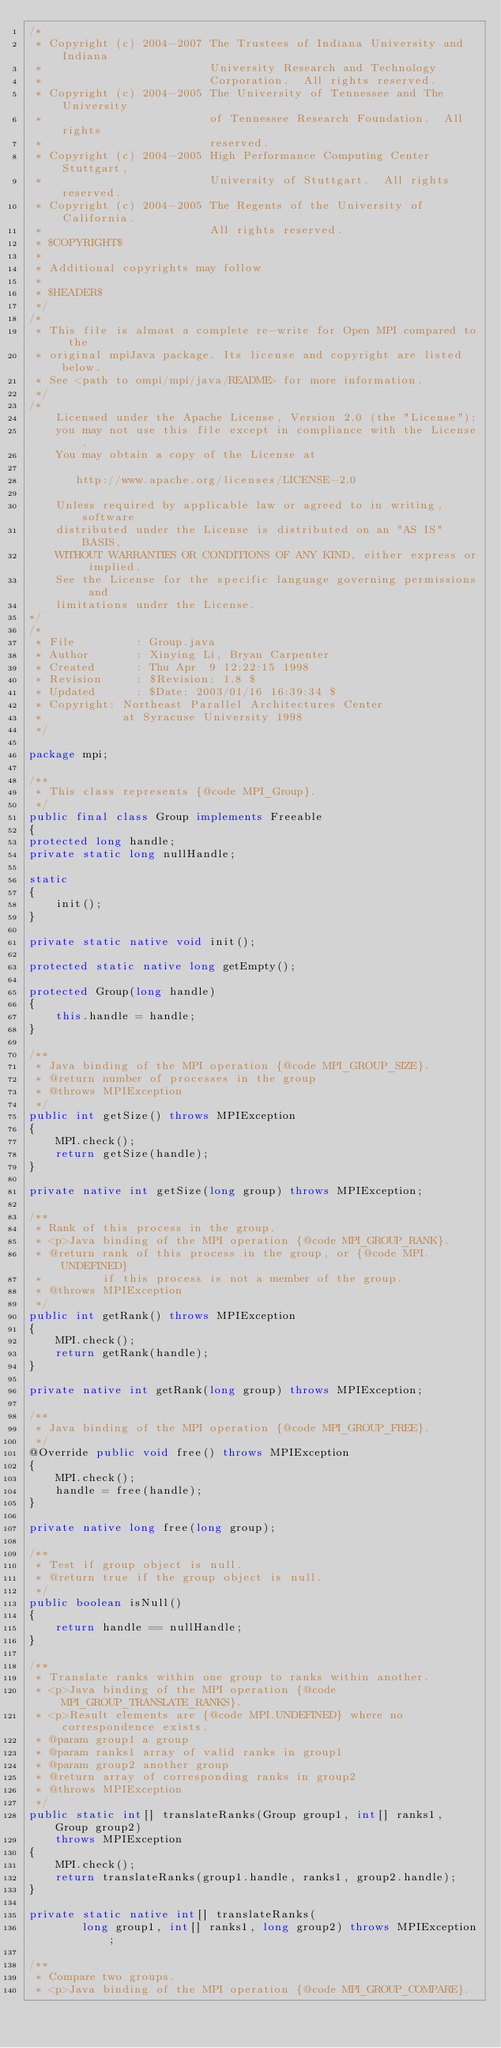Convert code to text. <code><loc_0><loc_0><loc_500><loc_500><_Java_>/*
 * Copyright (c) 2004-2007 The Trustees of Indiana University and Indiana
 *                         University Research and Technology
 *                         Corporation.  All rights reserved.
 * Copyright (c) 2004-2005 The University of Tennessee and The University
 *                         of Tennessee Research Foundation.  All rights
 *                         reserved.
 * Copyright (c) 2004-2005 High Performance Computing Center Stuttgart, 
 *                         University of Stuttgart.  All rights reserved.
 * Copyright (c) 2004-2005 The Regents of the University of California.
 *                         All rights reserved.
 * $COPYRIGHT$
 * 
 * Additional copyrights may follow
 * 
 * $HEADER$
 */
/*
 * This file is almost a complete re-write for Open MPI compared to the
 * original mpiJava package. Its license and copyright are listed below.
 * See <path to ompi/mpi/java/README> for more information.
 */
/*
    Licensed under the Apache License, Version 2.0 (the "License");
    you may not use this file except in compliance with the License.
    You may obtain a copy of the License at

       http://www.apache.org/licenses/LICENSE-2.0

    Unless required by applicable law or agreed to in writing, software
    distributed under the License is distributed on an "AS IS" BASIS,
    WITHOUT WARRANTIES OR CONDITIONS OF ANY KIND, either express or implied.
    See the License for the specific language governing permissions and
    limitations under the License.
*/
/*
 * File         : Group.java
 * Author       : Xinying Li, Bryan Carpenter
 * Created      : Thu Apr  9 12:22:15 1998
 * Revision     : $Revision: 1.8 $
 * Updated      : $Date: 2003/01/16 16:39:34 $
 * Copyright: Northeast Parallel Architectures Center
 *            at Syracuse University 1998
 */

package mpi;

/**
 * This class represents {@code MPI_Group}.
 */
public final class Group implements Freeable
{
protected long handle;
private static long nullHandle;

static
{
    init();
}

private static native void init();

protected static native long getEmpty();

protected Group(long handle)
{
    this.handle = handle;
}

/**
 * Java binding of the MPI operation {@code MPI_GROUP_SIZE}.
 * @return number of processes in the group
 * @throws MPIException 
 */
public int getSize() throws MPIException
{
    MPI.check();
    return getSize(handle);
}

private native int getSize(long group) throws MPIException;

/**
 * Rank of this process in the group.
 * <p>Java binding of the MPI operation {@code MPI_GROUP_RANK}.
 * @return rank of this process in the group, or {@code MPI.UNDEFINED}
 *         if this process is not a member of the group.
 * @throws MPIException
 */
public int getRank() throws MPIException
{
    MPI.check();
    return getRank(handle);
}

private native int getRank(long group) throws MPIException;

/**
 * Java binding of the MPI operation {@code MPI_GROUP_FREE}.
 */
@Override public void free() throws MPIException
{
    MPI.check();
    handle = free(handle);
}

private native long free(long group);

/**
 * Test if group object is null.
 * @return true if the group object is null.
 */
public boolean isNull()
{
    return handle == nullHandle;
}

/**
 * Translate ranks within one group to ranks within another.
 * <p>Java binding of the MPI operation {@code MPI_GROUP_TRANSLATE_RANKS}.
 * <p>Result elements are {@code MPI.UNDEFINED} where no correspondence exists.
 * @param group1 a group
 * @param ranks1 array of valid ranks in group1
 * @param group2 another group
 * @return array of corresponding ranks in group2
 * @throws MPIException 
 */
public static int[] translateRanks(Group group1, int[] ranks1, Group group2)
    throws MPIException
{
    MPI.check();
    return translateRanks(group1.handle, ranks1, group2.handle);
}

private static native int[] translateRanks(
        long group1, int[] ranks1, long group2) throws MPIException;

/**
 * Compare two groups.
 * <p>Java binding of the MPI operation {@code MPI_GROUP_COMPARE}.</code> 